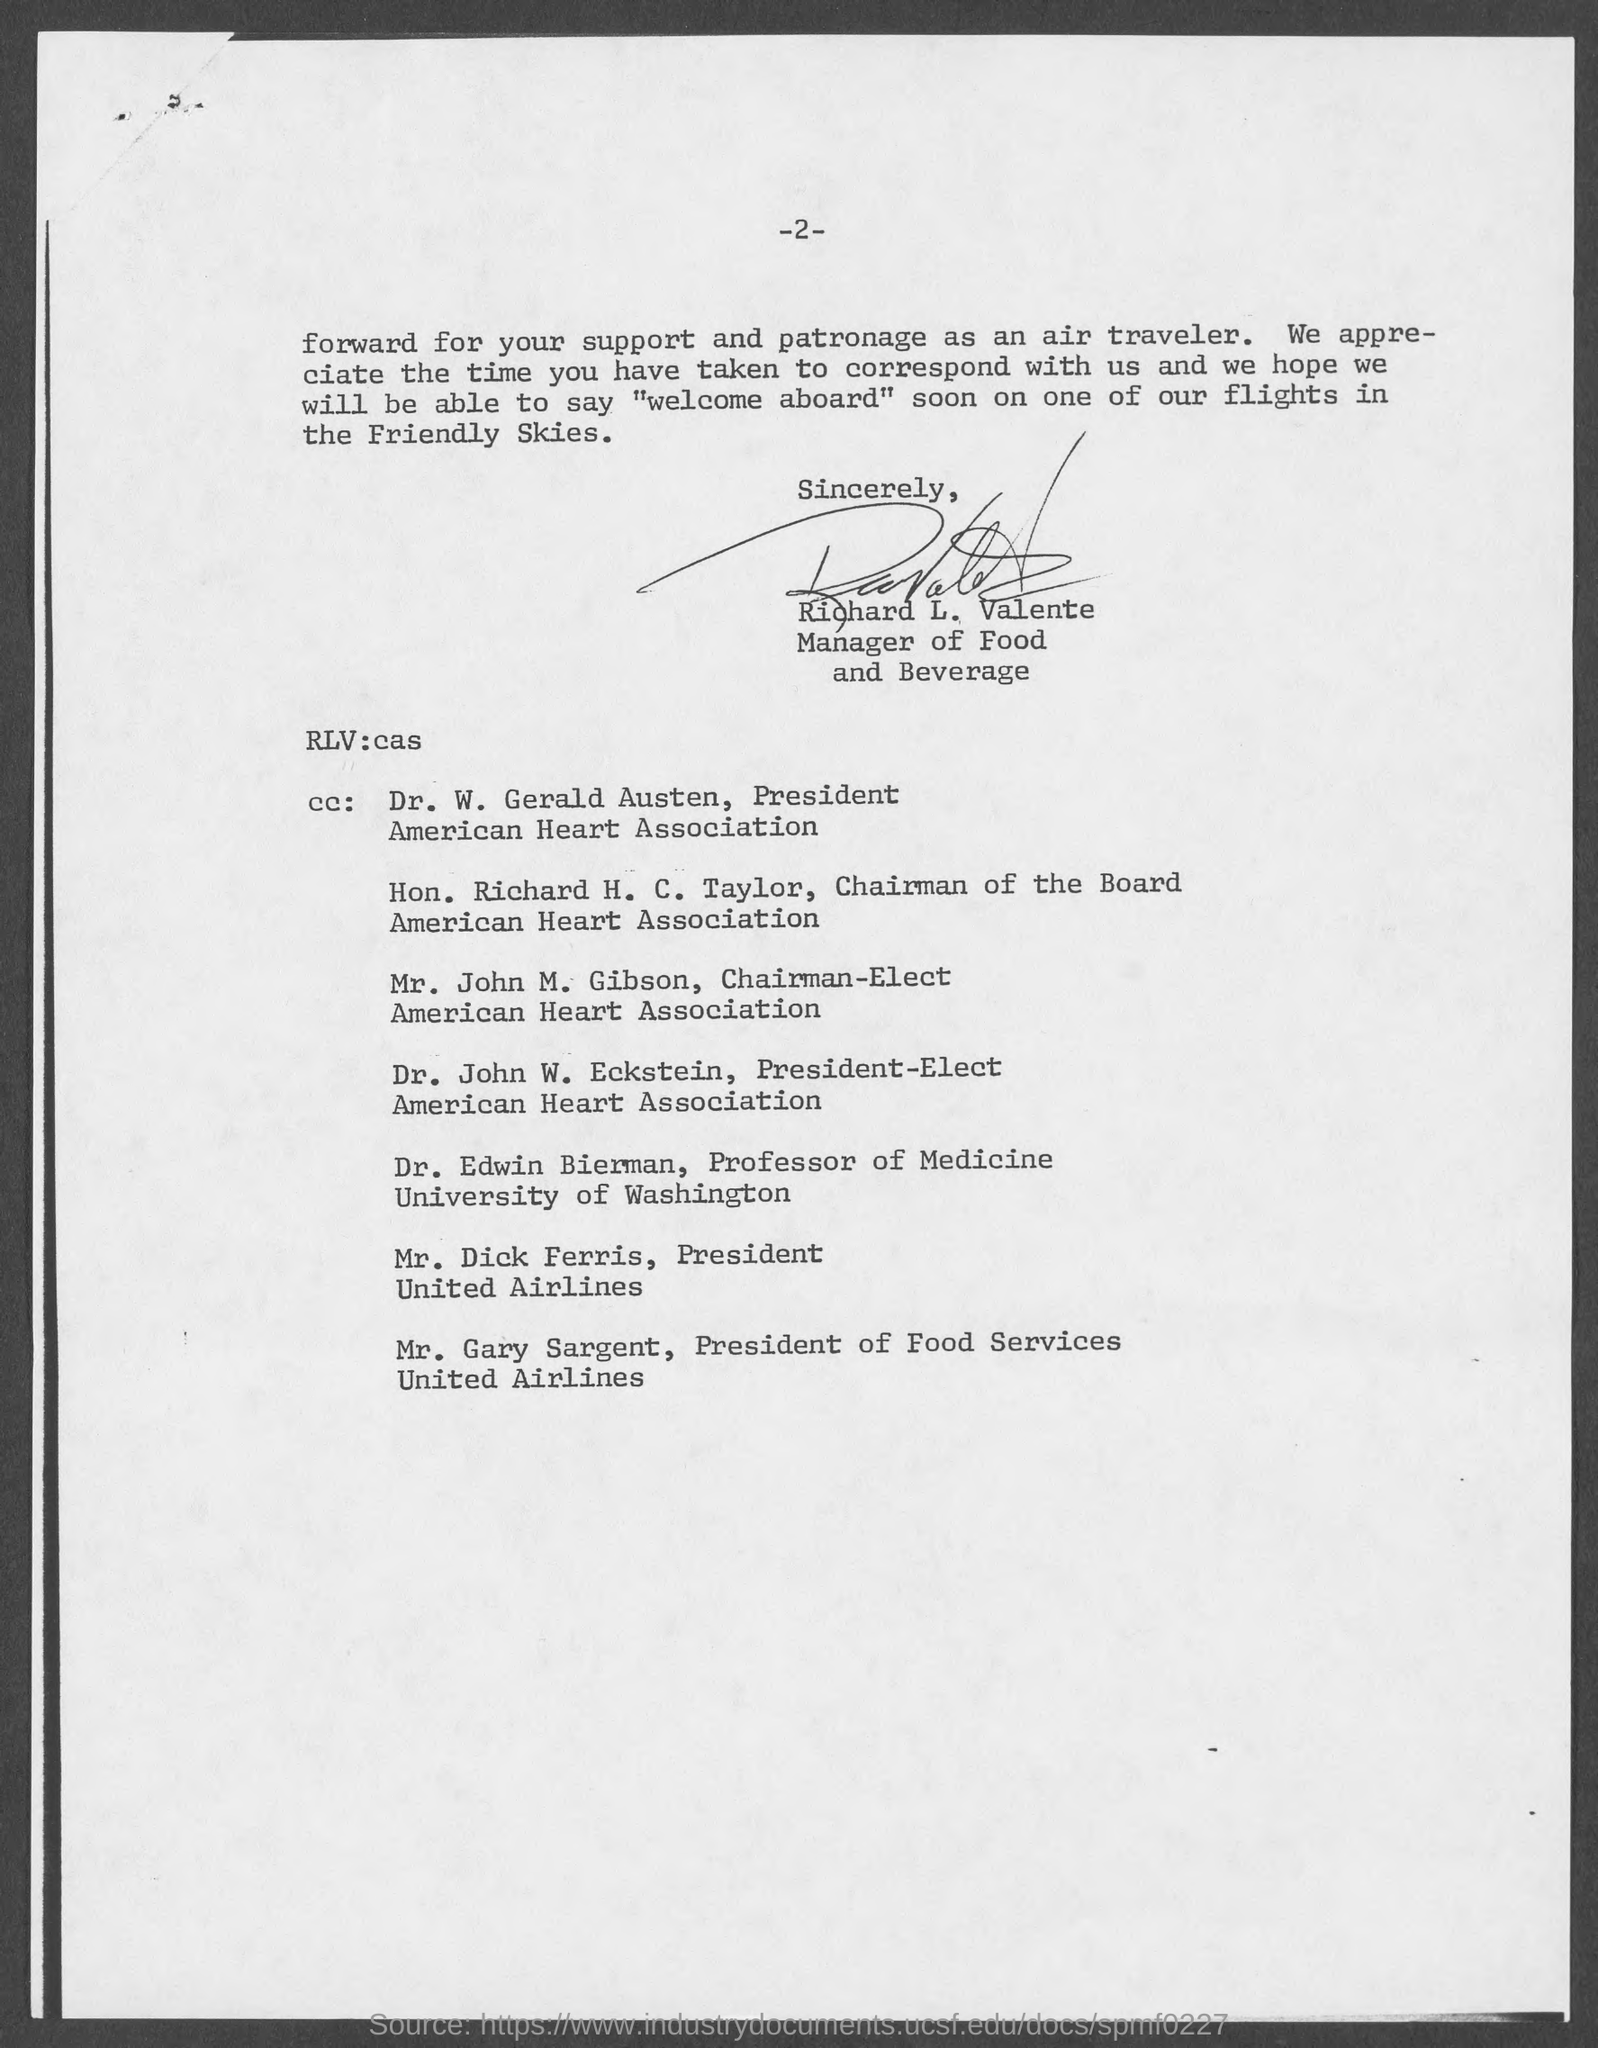Mention a couple of crucial points in this snapshot. Dr. W. Gerald Austen is the president of the American Heart Association. The Chairman of the Board of the American Heart Association is Hon. Richard H. C. Taylor. The President-Elect of the American Heart Association is Dr. John W. Eckstein. The manager of Food and Beverage is Richard L. Valente. I, Gary Sargent, am the President of Food Services at United Airlines. 